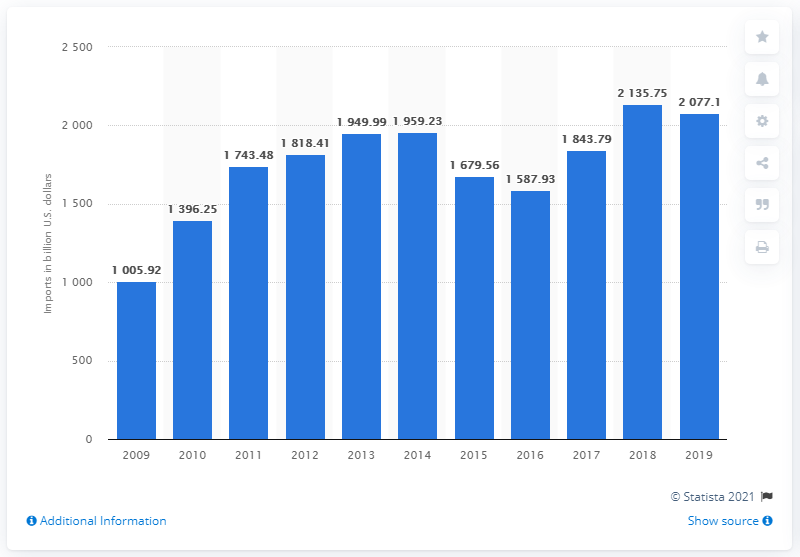Identify some key points in this picture. In 2019, China imported $2,077.1 million worth of goods. According to data from 2019, China's import value decreased by 2077.1%. 